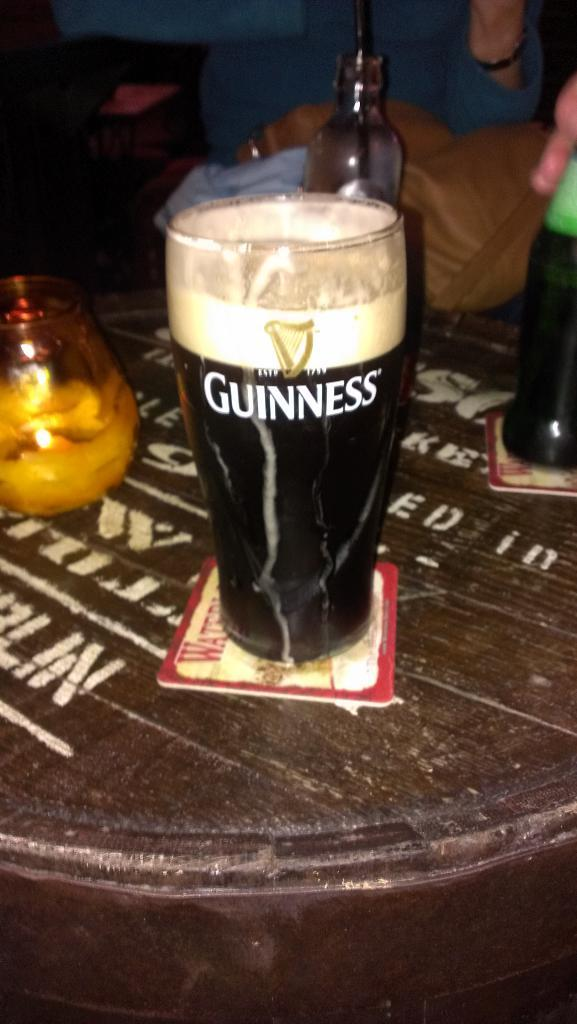<image>
Create a compact narrative representing the image presented. the word Guinness is on the glass of beer 